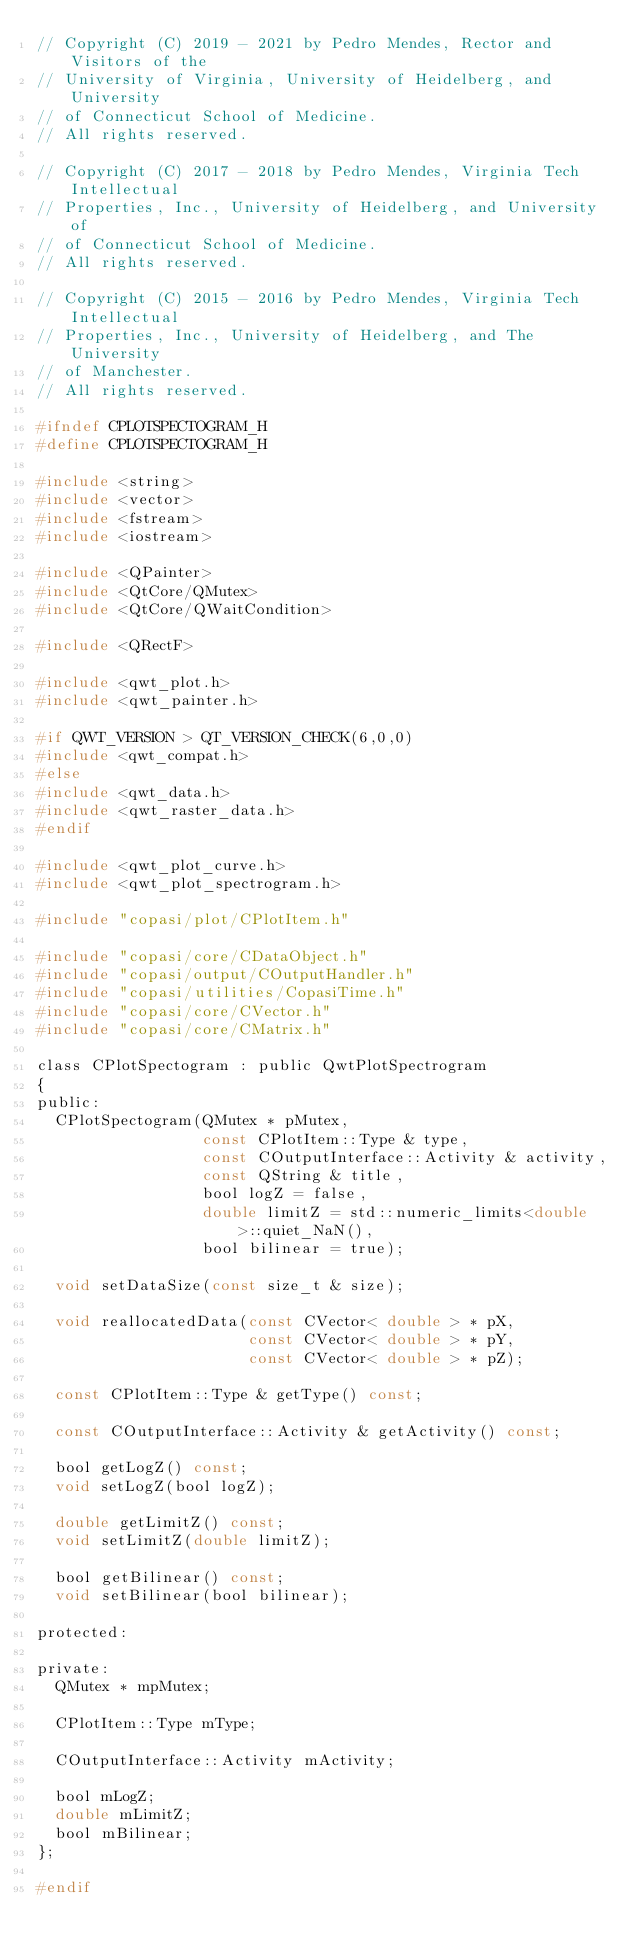<code> <loc_0><loc_0><loc_500><loc_500><_C_>// Copyright (C) 2019 - 2021 by Pedro Mendes, Rector and Visitors of the
// University of Virginia, University of Heidelberg, and University
// of Connecticut School of Medicine.
// All rights reserved.

// Copyright (C) 2017 - 2018 by Pedro Mendes, Virginia Tech Intellectual
// Properties, Inc., University of Heidelberg, and University of
// of Connecticut School of Medicine.
// All rights reserved.

// Copyright (C) 2015 - 2016 by Pedro Mendes, Virginia Tech Intellectual
// Properties, Inc., University of Heidelberg, and The University
// of Manchester.
// All rights reserved.

#ifndef CPLOTSPECTOGRAM_H
#define CPLOTSPECTOGRAM_H

#include <string>
#include <vector>
#include <fstream>
#include <iostream>

#include <QPainter>
#include <QtCore/QMutex>
#include <QtCore/QWaitCondition>

#include <QRectF>

#include <qwt_plot.h>
#include <qwt_painter.h>

#if QWT_VERSION > QT_VERSION_CHECK(6,0,0)
#include <qwt_compat.h>
#else
#include <qwt_data.h>
#include <qwt_raster_data.h>
#endif

#include <qwt_plot_curve.h>
#include <qwt_plot_spectrogram.h>

#include "copasi/plot/CPlotItem.h"

#include "copasi/core/CDataObject.h"
#include "copasi/output/COutputHandler.h"
#include "copasi/utilities/CopasiTime.h"
#include "copasi/core/CVector.h"
#include "copasi/core/CMatrix.h"

class CPlotSpectogram : public QwtPlotSpectrogram
{
public:
  CPlotSpectogram(QMutex * pMutex,
                  const CPlotItem::Type & type,
                  const COutputInterface::Activity & activity,
                  const QString & title,
                  bool logZ = false,
                  double limitZ = std::numeric_limits<double>::quiet_NaN(),
                  bool bilinear = true);

  void setDataSize(const size_t & size);

  void reallocatedData(const CVector< double > * pX,
                       const CVector< double > * pY,
                       const CVector< double > * pZ);

  const CPlotItem::Type & getType() const;

  const COutputInterface::Activity & getActivity() const;

  bool getLogZ() const;
  void setLogZ(bool logZ);

  double getLimitZ() const;
  void setLimitZ(double limitZ);

  bool getBilinear() const;
  void setBilinear(bool bilinear);

protected:

private:
  QMutex * mpMutex;

  CPlotItem::Type mType;

  COutputInterface::Activity mActivity;

  bool mLogZ;
  double mLimitZ;
  bool mBilinear;
};

#endif
</code> 